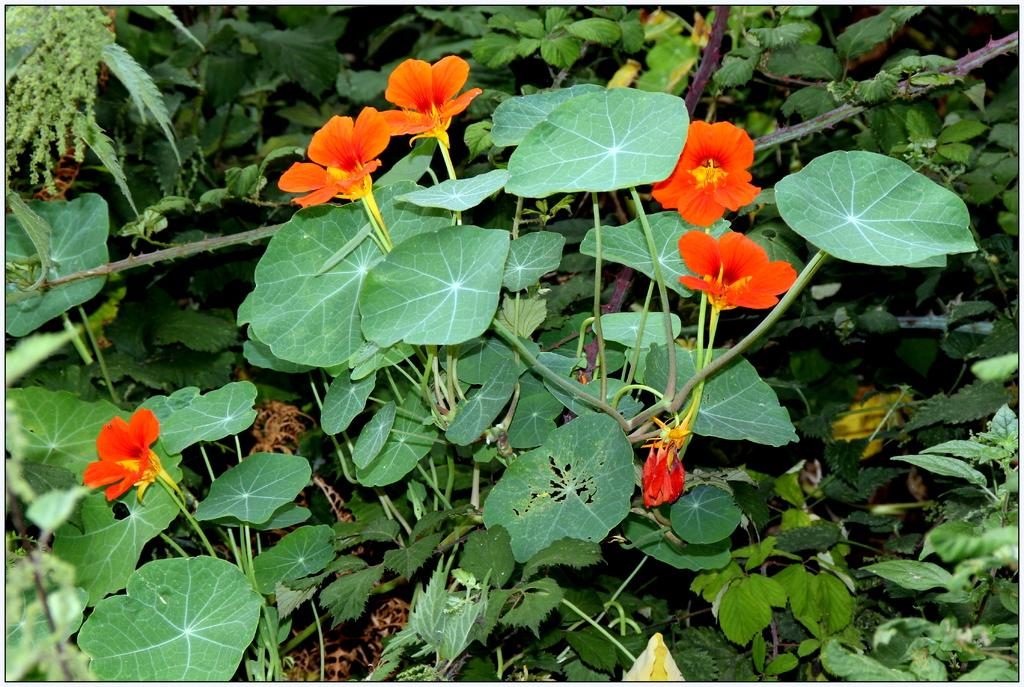What type of plant parts can be seen in the image? There are green leaves and stems in the image. What color are the flowers in the image? The flowers in the image are orange. What type of agreement is being discussed in the image? There is no discussion or agreement present in the image; it features green leaves, stems, and orange flowers. 